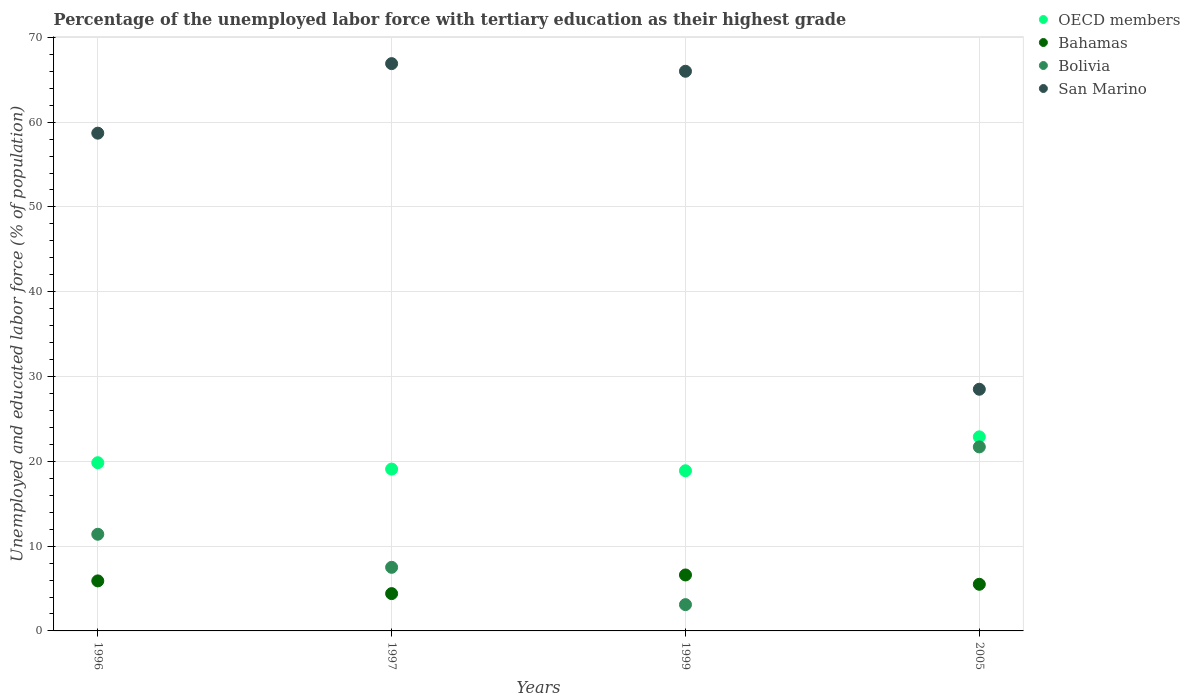What is the percentage of the unemployed labor force with tertiary education in OECD members in 1996?
Give a very brief answer. 19.84. Across all years, what is the maximum percentage of the unemployed labor force with tertiary education in Bahamas?
Provide a short and direct response. 6.6. Across all years, what is the minimum percentage of the unemployed labor force with tertiary education in OECD members?
Offer a very short reply. 18.89. In which year was the percentage of the unemployed labor force with tertiary education in Bolivia maximum?
Provide a short and direct response. 2005. In which year was the percentage of the unemployed labor force with tertiary education in OECD members minimum?
Your answer should be compact. 1999. What is the total percentage of the unemployed labor force with tertiary education in Bahamas in the graph?
Make the answer very short. 22.4. What is the difference between the percentage of the unemployed labor force with tertiary education in San Marino in 1996 and that in 1997?
Your answer should be compact. -8.2. What is the difference between the percentage of the unemployed labor force with tertiary education in San Marino in 1997 and the percentage of the unemployed labor force with tertiary education in Bolivia in 2005?
Provide a succinct answer. 45.2. What is the average percentage of the unemployed labor force with tertiary education in Bolivia per year?
Make the answer very short. 10.93. In the year 1996, what is the difference between the percentage of the unemployed labor force with tertiary education in San Marino and percentage of the unemployed labor force with tertiary education in Bahamas?
Offer a terse response. 52.8. In how many years, is the percentage of the unemployed labor force with tertiary education in OECD members greater than 58 %?
Your answer should be very brief. 0. What is the ratio of the percentage of the unemployed labor force with tertiary education in OECD members in 1997 to that in 1999?
Your answer should be compact. 1.01. Is the difference between the percentage of the unemployed labor force with tertiary education in San Marino in 1996 and 1999 greater than the difference between the percentage of the unemployed labor force with tertiary education in Bahamas in 1996 and 1999?
Your answer should be compact. No. What is the difference between the highest and the second highest percentage of the unemployed labor force with tertiary education in San Marino?
Offer a terse response. 0.9. What is the difference between the highest and the lowest percentage of the unemployed labor force with tertiary education in Bahamas?
Offer a terse response. 2.2. Is the sum of the percentage of the unemployed labor force with tertiary education in OECD members in 1996 and 1999 greater than the maximum percentage of the unemployed labor force with tertiary education in Bolivia across all years?
Offer a terse response. Yes. Is it the case that in every year, the sum of the percentage of the unemployed labor force with tertiary education in Bolivia and percentage of the unemployed labor force with tertiary education in San Marino  is greater than the sum of percentage of the unemployed labor force with tertiary education in Bahamas and percentage of the unemployed labor force with tertiary education in OECD members?
Give a very brief answer. Yes. Is it the case that in every year, the sum of the percentage of the unemployed labor force with tertiary education in OECD members and percentage of the unemployed labor force with tertiary education in San Marino  is greater than the percentage of the unemployed labor force with tertiary education in Bolivia?
Ensure brevity in your answer.  Yes. Does the percentage of the unemployed labor force with tertiary education in Bolivia monotonically increase over the years?
Keep it short and to the point. No. Is the percentage of the unemployed labor force with tertiary education in Bolivia strictly greater than the percentage of the unemployed labor force with tertiary education in San Marino over the years?
Your answer should be compact. No. Is the percentage of the unemployed labor force with tertiary education in Bahamas strictly less than the percentage of the unemployed labor force with tertiary education in San Marino over the years?
Your answer should be very brief. Yes. How many dotlines are there?
Provide a short and direct response. 4. How many years are there in the graph?
Your answer should be compact. 4. What is the difference between two consecutive major ticks on the Y-axis?
Provide a succinct answer. 10. Are the values on the major ticks of Y-axis written in scientific E-notation?
Provide a short and direct response. No. Does the graph contain grids?
Your answer should be very brief. Yes. Where does the legend appear in the graph?
Offer a terse response. Top right. How are the legend labels stacked?
Your answer should be compact. Vertical. What is the title of the graph?
Your answer should be compact. Percentage of the unemployed labor force with tertiary education as their highest grade. What is the label or title of the Y-axis?
Make the answer very short. Unemployed and educated labor force (% of population). What is the Unemployed and educated labor force (% of population) in OECD members in 1996?
Provide a short and direct response. 19.84. What is the Unemployed and educated labor force (% of population) in Bahamas in 1996?
Provide a short and direct response. 5.9. What is the Unemployed and educated labor force (% of population) in Bolivia in 1996?
Offer a terse response. 11.4. What is the Unemployed and educated labor force (% of population) in San Marino in 1996?
Your answer should be compact. 58.7. What is the Unemployed and educated labor force (% of population) of OECD members in 1997?
Offer a very short reply. 19.09. What is the Unemployed and educated labor force (% of population) of Bahamas in 1997?
Give a very brief answer. 4.4. What is the Unemployed and educated labor force (% of population) in Bolivia in 1997?
Make the answer very short. 7.5. What is the Unemployed and educated labor force (% of population) of San Marino in 1997?
Ensure brevity in your answer.  66.9. What is the Unemployed and educated labor force (% of population) of OECD members in 1999?
Provide a short and direct response. 18.89. What is the Unemployed and educated labor force (% of population) of Bahamas in 1999?
Your answer should be very brief. 6.6. What is the Unemployed and educated labor force (% of population) of Bolivia in 1999?
Offer a very short reply. 3.1. What is the Unemployed and educated labor force (% of population) of San Marino in 1999?
Offer a very short reply. 66. What is the Unemployed and educated labor force (% of population) of OECD members in 2005?
Offer a terse response. 22.89. What is the Unemployed and educated labor force (% of population) in Bolivia in 2005?
Make the answer very short. 21.7. Across all years, what is the maximum Unemployed and educated labor force (% of population) in OECD members?
Provide a short and direct response. 22.89. Across all years, what is the maximum Unemployed and educated labor force (% of population) in Bahamas?
Your answer should be compact. 6.6. Across all years, what is the maximum Unemployed and educated labor force (% of population) in Bolivia?
Keep it short and to the point. 21.7. Across all years, what is the maximum Unemployed and educated labor force (% of population) in San Marino?
Ensure brevity in your answer.  66.9. Across all years, what is the minimum Unemployed and educated labor force (% of population) in OECD members?
Offer a terse response. 18.89. Across all years, what is the minimum Unemployed and educated labor force (% of population) in Bahamas?
Provide a short and direct response. 4.4. Across all years, what is the minimum Unemployed and educated labor force (% of population) of Bolivia?
Provide a succinct answer. 3.1. What is the total Unemployed and educated labor force (% of population) of OECD members in the graph?
Your response must be concise. 80.7. What is the total Unemployed and educated labor force (% of population) in Bahamas in the graph?
Offer a very short reply. 22.4. What is the total Unemployed and educated labor force (% of population) in Bolivia in the graph?
Give a very brief answer. 43.7. What is the total Unemployed and educated labor force (% of population) of San Marino in the graph?
Give a very brief answer. 220.1. What is the difference between the Unemployed and educated labor force (% of population) of OECD members in 1996 and that in 1997?
Your response must be concise. 0.75. What is the difference between the Unemployed and educated labor force (% of population) of Bahamas in 1996 and that in 1997?
Make the answer very short. 1.5. What is the difference between the Unemployed and educated labor force (% of population) in San Marino in 1996 and that in 1997?
Your answer should be very brief. -8.2. What is the difference between the Unemployed and educated labor force (% of population) of OECD members in 1996 and that in 1999?
Your answer should be compact. 0.95. What is the difference between the Unemployed and educated labor force (% of population) in Bahamas in 1996 and that in 1999?
Your answer should be compact. -0.7. What is the difference between the Unemployed and educated labor force (% of population) in Bolivia in 1996 and that in 1999?
Provide a succinct answer. 8.3. What is the difference between the Unemployed and educated labor force (% of population) in OECD members in 1996 and that in 2005?
Ensure brevity in your answer.  -3.05. What is the difference between the Unemployed and educated labor force (% of population) of Bolivia in 1996 and that in 2005?
Your answer should be compact. -10.3. What is the difference between the Unemployed and educated labor force (% of population) in San Marino in 1996 and that in 2005?
Give a very brief answer. 30.2. What is the difference between the Unemployed and educated labor force (% of population) of OECD members in 1997 and that in 1999?
Offer a terse response. 0.2. What is the difference between the Unemployed and educated labor force (% of population) in Bolivia in 1997 and that in 1999?
Your response must be concise. 4.4. What is the difference between the Unemployed and educated labor force (% of population) of OECD members in 1997 and that in 2005?
Give a very brief answer. -3.8. What is the difference between the Unemployed and educated labor force (% of population) in Bolivia in 1997 and that in 2005?
Give a very brief answer. -14.2. What is the difference between the Unemployed and educated labor force (% of population) in San Marino in 1997 and that in 2005?
Your response must be concise. 38.4. What is the difference between the Unemployed and educated labor force (% of population) in OECD members in 1999 and that in 2005?
Keep it short and to the point. -4. What is the difference between the Unemployed and educated labor force (% of population) in Bolivia in 1999 and that in 2005?
Offer a terse response. -18.6. What is the difference between the Unemployed and educated labor force (% of population) in San Marino in 1999 and that in 2005?
Your answer should be compact. 37.5. What is the difference between the Unemployed and educated labor force (% of population) in OECD members in 1996 and the Unemployed and educated labor force (% of population) in Bahamas in 1997?
Your response must be concise. 15.44. What is the difference between the Unemployed and educated labor force (% of population) in OECD members in 1996 and the Unemployed and educated labor force (% of population) in Bolivia in 1997?
Keep it short and to the point. 12.34. What is the difference between the Unemployed and educated labor force (% of population) of OECD members in 1996 and the Unemployed and educated labor force (% of population) of San Marino in 1997?
Give a very brief answer. -47.06. What is the difference between the Unemployed and educated labor force (% of population) in Bahamas in 1996 and the Unemployed and educated labor force (% of population) in San Marino in 1997?
Keep it short and to the point. -61. What is the difference between the Unemployed and educated labor force (% of population) in Bolivia in 1996 and the Unemployed and educated labor force (% of population) in San Marino in 1997?
Your answer should be very brief. -55.5. What is the difference between the Unemployed and educated labor force (% of population) of OECD members in 1996 and the Unemployed and educated labor force (% of population) of Bahamas in 1999?
Keep it short and to the point. 13.24. What is the difference between the Unemployed and educated labor force (% of population) in OECD members in 1996 and the Unemployed and educated labor force (% of population) in Bolivia in 1999?
Your answer should be compact. 16.74. What is the difference between the Unemployed and educated labor force (% of population) in OECD members in 1996 and the Unemployed and educated labor force (% of population) in San Marino in 1999?
Your response must be concise. -46.16. What is the difference between the Unemployed and educated labor force (% of population) of Bahamas in 1996 and the Unemployed and educated labor force (% of population) of San Marino in 1999?
Make the answer very short. -60.1. What is the difference between the Unemployed and educated labor force (% of population) of Bolivia in 1996 and the Unemployed and educated labor force (% of population) of San Marino in 1999?
Ensure brevity in your answer.  -54.6. What is the difference between the Unemployed and educated labor force (% of population) of OECD members in 1996 and the Unemployed and educated labor force (% of population) of Bahamas in 2005?
Make the answer very short. 14.34. What is the difference between the Unemployed and educated labor force (% of population) of OECD members in 1996 and the Unemployed and educated labor force (% of population) of Bolivia in 2005?
Make the answer very short. -1.86. What is the difference between the Unemployed and educated labor force (% of population) of OECD members in 1996 and the Unemployed and educated labor force (% of population) of San Marino in 2005?
Provide a short and direct response. -8.66. What is the difference between the Unemployed and educated labor force (% of population) in Bahamas in 1996 and the Unemployed and educated labor force (% of population) in Bolivia in 2005?
Give a very brief answer. -15.8. What is the difference between the Unemployed and educated labor force (% of population) of Bahamas in 1996 and the Unemployed and educated labor force (% of population) of San Marino in 2005?
Your response must be concise. -22.6. What is the difference between the Unemployed and educated labor force (% of population) of Bolivia in 1996 and the Unemployed and educated labor force (% of population) of San Marino in 2005?
Your answer should be very brief. -17.1. What is the difference between the Unemployed and educated labor force (% of population) of OECD members in 1997 and the Unemployed and educated labor force (% of population) of Bahamas in 1999?
Offer a very short reply. 12.49. What is the difference between the Unemployed and educated labor force (% of population) in OECD members in 1997 and the Unemployed and educated labor force (% of population) in Bolivia in 1999?
Provide a short and direct response. 15.99. What is the difference between the Unemployed and educated labor force (% of population) of OECD members in 1997 and the Unemployed and educated labor force (% of population) of San Marino in 1999?
Give a very brief answer. -46.91. What is the difference between the Unemployed and educated labor force (% of population) of Bahamas in 1997 and the Unemployed and educated labor force (% of population) of San Marino in 1999?
Provide a succinct answer. -61.6. What is the difference between the Unemployed and educated labor force (% of population) in Bolivia in 1997 and the Unemployed and educated labor force (% of population) in San Marino in 1999?
Provide a short and direct response. -58.5. What is the difference between the Unemployed and educated labor force (% of population) in OECD members in 1997 and the Unemployed and educated labor force (% of population) in Bahamas in 2005?
Make the answer very short. 13.59. What is the difference between the Unemployed and educated labor force (% of population) in OECD members in 1997 and the Unemployed and educated labor force (% of population) in Bolivia in 2005?
Keep it short and to the point. -2.61. What is the difference between the Unemployed and educated labor force (% of population) of OECD members in 1997 and the Unemployed and educated labor force (% of population) of San Marino in 2005?
Offer a terse response. -9.41. What is the difference between the Unemployed and educated labor force (% of population) in Bahamas in 1997 and the Unemployed and educated labor force (% of population) in Bolivia in 2005?
Keep it short and to the point. -17.3. What is the difference between the Unemployed and educated labor force (% of population) of Bahamas in 1997 and the Unemployed and educated labor force (% of population) of San Marino in 2005?
Your response must be concise. -24.1. What is the difference between the Unemployed and educated labor force (% of population) in OECD members in 1999 and the Unemployed and educated labor force (% of population) in Bahamas in 2005?
Provide a succinct answer. 13.39. What is the difference between the Unemployed and educated labor force (% of population) in OECD members in 1999 and the Unemployed and educated labor force (% of population) in Bolivia in 2005?
Provide a short and direct response. -2.81. What is the difference between the Unemployed and educated labor force (% of population) in OECD members in 1999 and the Unemployed and educated labor force (% of population) in San Marino in 2005?
Provide a succinct answer. -9.61. What is the difference between the Unemployed and educated labor force (% of population) of Bahamas in 1999 and the Unemployed and educated labor force (% of population) of Bolivia in 2005?
Your answer should be compact. -15.1. What is the difference between the Unemployed and educated labor force (% of population) of Bahamas in 1999 and the Unemployed and educated labor force (% of population) of San Marino in 2005?
Your answer should be compact. -21.9. What is the difference between the Unemployed and educated labor force (% of population) in Bolivia in 1999 and the Unemployed and educated labor force (% of population) in San Marino in 2005?
Give a very brief answer. -25.4. What is the average Unemployed and educated labor force (% of population) in OECD members per year?
Your response must be concise. 20.18. What is the average Unemployed and educated labor force (% of population) in Bolivia per year?
Your answer should be compact. 10.93. What is the average Unemployed and educated labor force (% of population) in San Marino per year?
Provide a succinct answer. 55.02. In the year 1996, what is the difference between the Unemployed and educated labor force (% of population) in OECD members and Unemployed and educated labor force (% of population) in Bahamas?
Provide a short and direct response. 13.94. In the year 1996, what is the difference between the Unemployed and educated labor force (% of population) in OECD members and Unemployed and educated labor force (% of population) in Bolivia?
Offer a very short reply. 8.44. In the year 1996, what is the difference between the Unemployed and educated labor force (% of population) of OECD members and Unemployed and educated labor force (% of population) of San Marino?
Ensure brevity in your answer.  -38.86. In the year 1996, what is the difference between the Unemployed and educated labor force (% of population) of Bahamas and Unemployed and educated labor force (% of population) of San Marino?
Offer a very short reply. -52.8. In the year 1996, what is the difference between the Unemployed and educated labor force (% of population) of Bolivia and Unemployed and educated labor force (% of population) of San Marino?
Give a very brief answer. -47.3. In the year 1997, what is the difference between the Unemployed and educated labor force (% of population) in OECD members and Unemployed and educated labor force (% of population) in Bahamas?
Offer a terse response. 14.69. In the year 1997, what is the difference between the Unemployed and educated labor force (% of population) in OECD members and Unemployed and educated labor force (% of population) in Bolivia?
Offer a terse response. 11.59. In the year 1997, what is the difference between the Unemployed and educated labor force (% of population) in OECD members and Unemployed and educated labor force (% of population) in San Marino?
Your answer should be very brief. -47.81. In the year 1997, what is the difference between the Unemployed and educated labor force (% of population) in Bahamas and Unemployed and educated labor force (% of population) in San Marino?
Your answer should be compact. -62.5. In the year 1997, what is the difference between the Unemployed and educated labor force (% of population) of Bolivia and Unemployed and educated labor force (% of population) of San Marino?
Provide a succinct answer. -59.4. In the year 1999, what is the difference between the Unemployed and educated labor force (% of population) in OECD members and Unemployed and educated labor force (% of population) in Bahamas?
Provide a succinct answer. 12.29. In the year 1999, what is the difference between the Unemployed and educated labor force (% of population) of OECD members and Unemployed and educated labor force (% of population) of Bolivia?
Provide a short and direct response. 15.79. In the year 1999, what is the difference between the Unemployed and educated labor force (% of population) of OECD members and Unemployed and educated labor force (% of population) of San Marino?
Give a very brief answer. -47.11. In the year 1999, what is the difference between the Unemployed and educated labor force (% of population) in Bahamas and Unemployed and educated labor force (% of population) in San Marino?
Your response must be concise. -59.4. In the year 1999, what is the difference between the Unemployed and educated labor force (% of population) of Bolivia and Unemployed and educated labor force (% of population) of San Marino?
Your answer should be compact. -62.9. In the year 2005, what is the difference between the Unemployed and educated labor force (% of population) of OECD members and Unemployed and educated labor force (% of population) of Bahamas?
Keep it short and to the point. 17.39. In the year 2005, what is the difference between the Unemployed and educated labor force (% of population) in OECD members and Unemployed and educated labor force (% of population) in Bolivia?
Keep it short and to the point. 1.19. In the year 2005, what is the difference between the Unemployed and educated labor force (% of population) in OECD members and Unemployed and educated labor force (% of population) in San Marino?
Your answer should be very brief. -5.61. In the year 2005, what is the difference between the Unemployed and educated labor force (% of population) in Bahamas and Unemployed and educated labor force (% of population) in Bolivia?
Your answer should be compact. -16.2. In the year 2005, what is the difference between the Unemployed and educated labor force (% of population) in Bahamas and Unemployed and educated labor force (% of population) in San Marino?
Ensure brevity in your answer.  -23. What is the ratio of the Unemployed and educated labor force (% of population) of OECD members in 1996 to that in 1997?
Make the answer very short. 1.04. What is the ratio of the Unemployed and educated labor force (% of population) in Bahamas in 1996 to that in 1997?
Offer a very short reply. 1.34. What is the ratio of the Unemployed and educated labor force (% of population) in Bolivia in 1996 to that in 1997?
Ensure brevity in your answer.  1.52. What is the ratio of the Unemployed and educated labor force (% of population) of San Marino in 1996 to that in 1997?
Provide a succinct answer. 0.88. What is the ratio of the Unemployed and educated labor force (% of population) in OECD members in 1996 to that in 1999?
Provide a succinct answer. 1.05. What is the ratio of the Unemployed and educated labor force (% of population) of Bahamas in 1996 to that in 1999?
Provide a succinct answer. 0.89. What is the ratio of the Unemployed and educated labor force (% of population) of Bolivia in 1996 to that in 1999?
Make the answer very short. 3.68. What is the ratio of the Unemployed and educated labor force (% of population) of San Marino in 1996 to that in 1999?
Give a very brief answer. 0.89. What is the ratio of the Unemployed and educated labor force (% of population) in OECD members in 1996 to that in 2005?
Offer a very short reply. 0.87. What is the ratio of the Unemployed and educated labor force (% of population) of Bahamas in 1996 to that in 2005?
Your response must be concise. 1.07. What is the ratio of the Unemployed and educated labor force (% of population) in Bolivia in 1996 to that in 2005?
Your response must be concise. 0.53. What is the ratio of the Unemployed and educated labor force (% of population) of San Marino in 1996 to that in 2005?
Your answer should be compact. 2.06. What is the ratio of the Unemployed and educated labor force (% of population) of OECD members in 1997 to that in 1999?
Give a very brief answer. 1.01. What is the ratio of the Unemployed and educated labor force (% of population) in Bahamas in 1997 to that in 1999?
Provide a succinct answer. 0.67. What is the ratio of the Unemployed and educated labor force (% of population) in Bolivia in 1997 to that in 1999?
Your answer should be very brief. 2.42. What is the ratio of the Unemployed and educated labor force (% of population) in San Marino in 1997 to that in 1999?
Give a very brief answer. 1.01. What is the ratio of the Unemployed and educated labor force (% of population) in OECD members in 1997 to that in 2005?
Provide a succinct answer. 0.83. What is the ratio of the Unemployed and educated labor force (% of population) in Bahamas in 1997 to that in 2005?
Offer a terse response. 0.8. What is the ratio of the Unemployed and educated labor force (% of population) in Bolivia in 1997 to that in 2005?
Make the answer very short. 0.35. What is the ratio of the Unemployed and educated labor force (% of population) of San Marino in 1997 to that in 2005?
Provide a succinct answer. 2.35. What is the ratio of the Unemployed and educated labor force (% of population) of OECD members in 1999 to that in 2005?
Provide a short and direct response. 0.83. What is the ratio of the Unemployed and educated labor force (% of population) of Bolivia in 1999 to that in 2005?
Your answer should be compact. 0.14. What is the ratio of the Unemployed and educated labor force (% of population) in San Marino in 1999 to that in 2005?
Your answer should be very brief. 2.32. What is the difference between the highest and the second highest Unemployed and educated labor force (% of population) of OECD members?
Ensure brevity in your answer.  3.05. What is the difference between the highest and the second highest Unemployed and educated labor force (% of population) of Bahamas?
Give a very brief answer. 0.7. What is the difference between the highest and the lowest Unemployed and educated labor force (% of population) of OECD members?
Your answer should be compact. 4. What is the difference between the highest and the lowest Unemployed and educated labor force (% of population) in San Marino?
Provide a short and direct response. 38.4. 